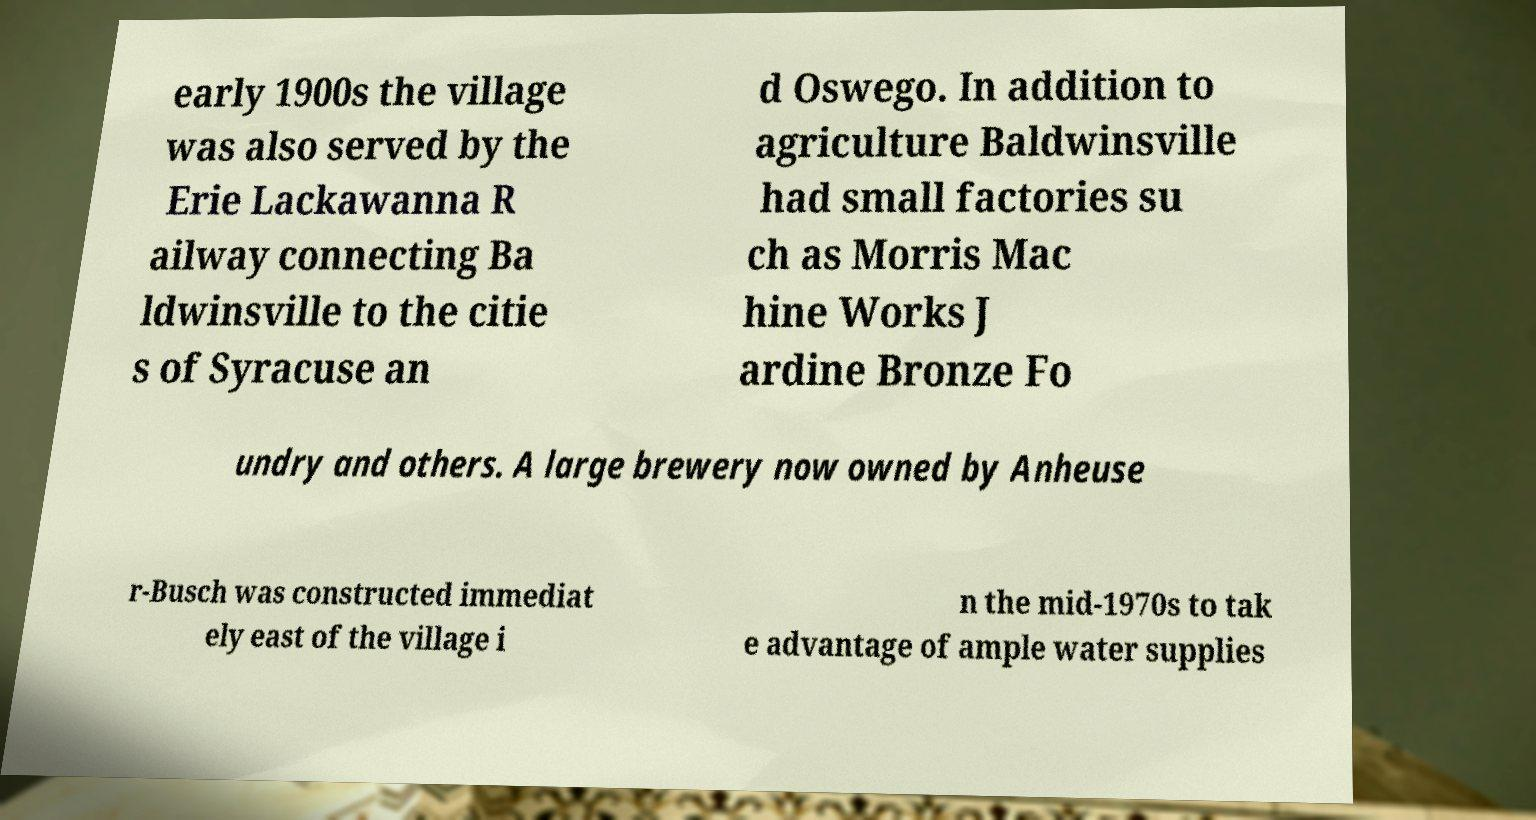Please read and relay the text visible in this image. What does it say? early 1900s the village was also served by the Erie Lackawanna R ailway connecting Ba ldwinsville to the citie s of Syracuse an d Oswego. In addition to agriculture Baldwinsville had small factories su ch as Morris Mac hine Works J ardine Bronze Fo undry and others. A large brewery now owned by Anheuse r-Busch was constructed immediat ely east of the village i n the mid-1970s to tak e advantage of ample water supplies 